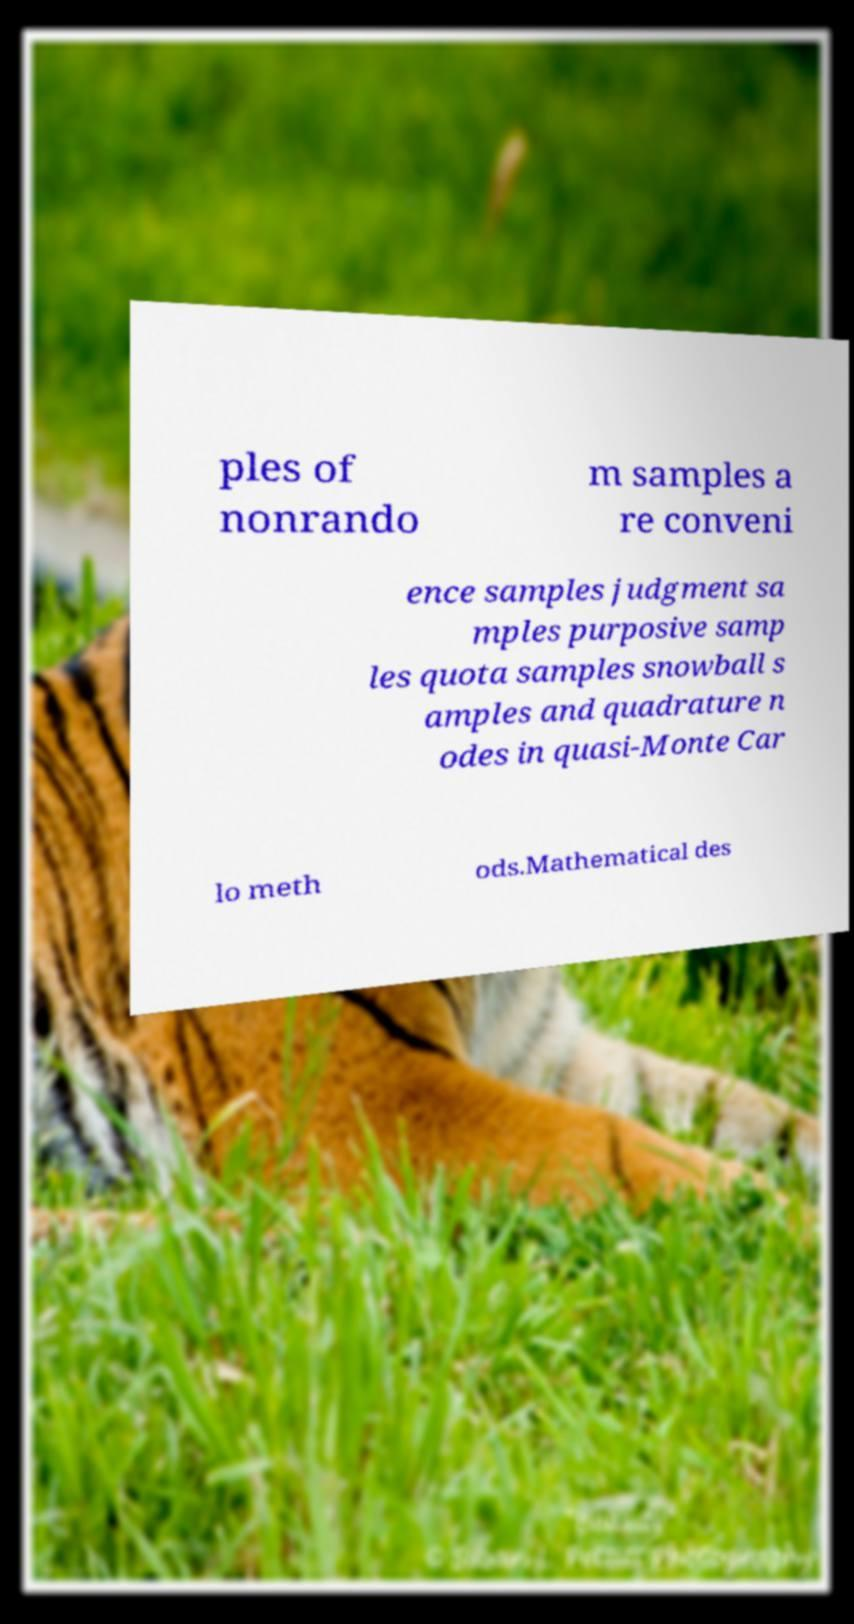For documentation purposes, I need the text within this image transcribed. Could you provide that? ples of nonrando m samples a re conveni ence samples judgment sa mples purposive samp les quota samples snowball s amples and quadrature n odes in quasi-Monte Car lo meth ods.Mathematical des 